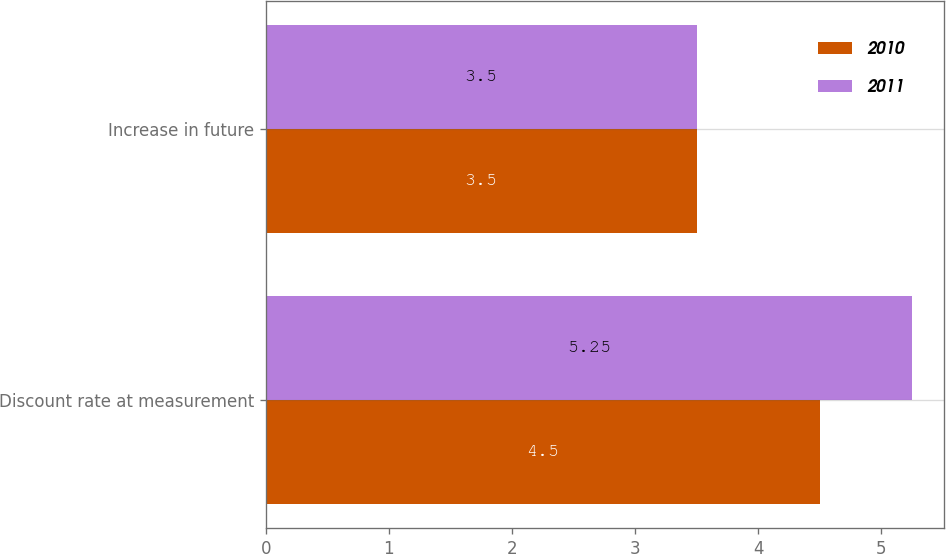<chart> <loc_0><loc_0><loc_500><loc_500><stacked_bar_chart><ecel><fcel>Discount rate at measurement<fcel>Increase in future<nl><fcel>2010<fcel>4.5<fcel>3.5<nl><fcel>2011<fcel>5.25<fcel>3.5<nl></chart> 